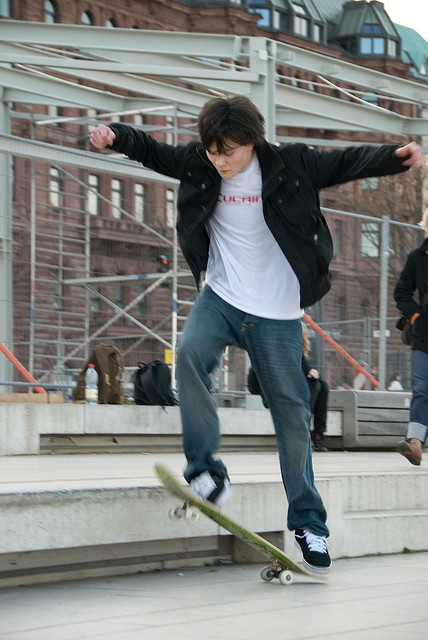Describe the objects in this image and their specific colors. I can see people in gray, black, blue, and lavender tones, people in gray, black, blue, and darkblue tones, skateboard in gray, darkgreen, olive, and darkgray tones, backpack in gray and black tones, and backpack in gray, black, darkblue, and purple tones in this image. 